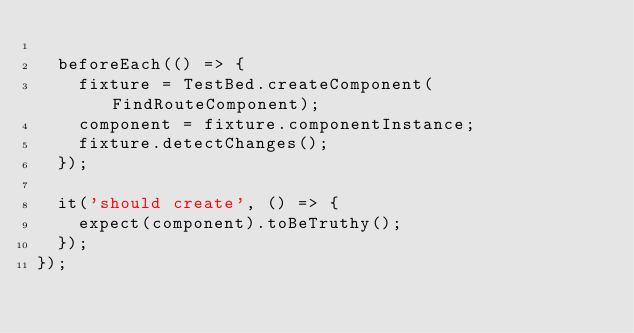Convert code to text. <code><loc_0><loc_0><loc_500><loc_500><_TypeScript_>
  beforeEach(() => {
    fixture = TestBed.createComponent(FindRouteComponent);
    component = fixture.componentInstance;
    fixture.detectChanges();
  });

  it('should create', () => {
    expect(component).toBeTruthy();
  });
});
</code> 